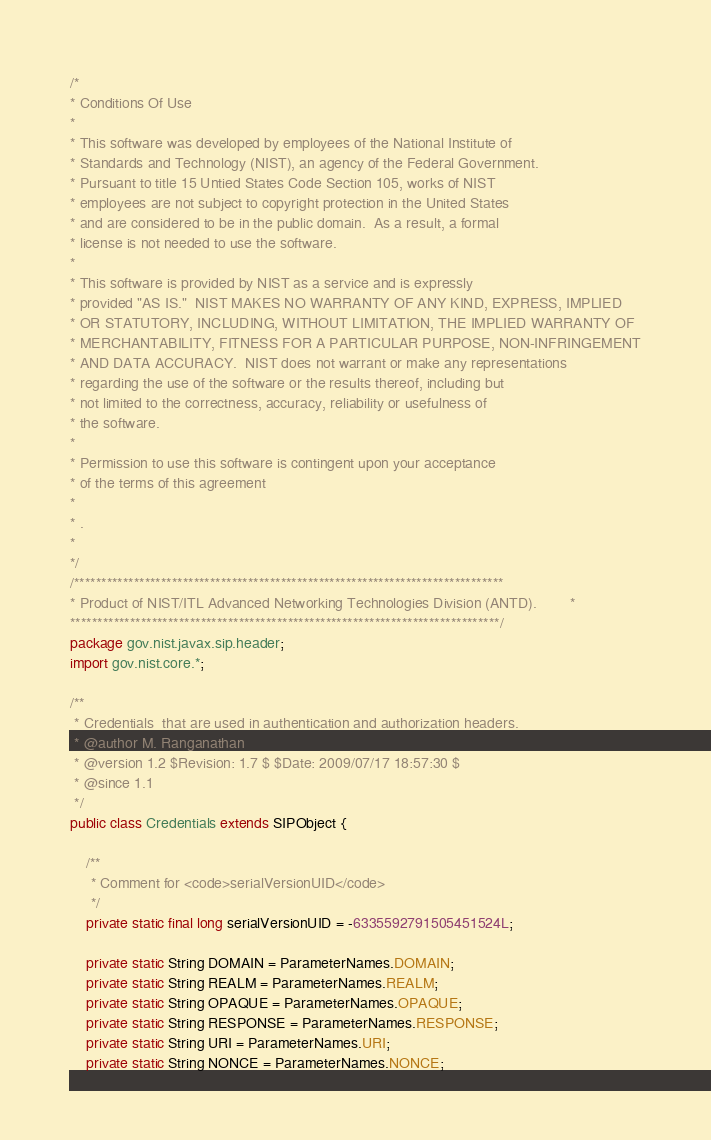Convert code to text. <code><loc_0><loc_0><loc_500><loc_500><_Java_>/*
* Conditions Of Use
*
* This software was developed by employees of the National Institute of
* Standards and Technology (NIST), an agency of the Federal Government.
* Pursuant to title 15 Untied States Code Section 105, works of NIST
* employees are not subject to copyright protection in the United States
* and are considered to be in the public domain.  As a result, a formal
* license is not needed to use the software.
*
* This software is provided by NIST as a service and is expressly
* provided "AS IS."  NIST MAKES NO WARRANTY OF ANY KIND, EXPRESS, IMPLIED
* OR STATUTORY, INCLUDING, WITHOUT LIMITATION, THE IMPLIED WARRANTY OF
* MERCHANTABILITY, FITNESS FOR A PARTICULAR PURPOSE, NON-INFRINGEMENT
* AND DATA ACCURACY.  NIST does not warrant or make any representations
* regarding the use of the software or the results thereof, including but
* not limited to the correctness, accuracy, reliability or usefulness of
* the software.
*
* Permission to use this software is contingent upon your acceptance
* of the terms of this agreement
*
* .
*
*/
/*******************************************************************************
* Product of NIST/ITL Advanced Networking Technologies Division (ANTD).        *
*******************************************************************************/
package gov.nist.javax.sip.header;
import gov.nist.core.*;

/**
 * Credentials  that are used in authentication and authorization headers.
 * @author M. Ranganathan
 * @version 1.2 $Revision: 1.7 $ $Date: 2009/07/17 18:57:30 $
 * @since 1.1
 */
public class Credentials extends SIPObject {

    /**
     * Comment for <code>serialVersionUID</code>
     */
    private static final long serialVersionUID = -6335592791505451524L;

    private static String DOMAIN = ParameterNames.DOMAIN;
    private static String REALM = ParameterNames.REALM;
    private static String OPAQUE = ParameterNames.OPAQUE;
    private static String RESPONSE = ParameterNames.RESPONSE;
    private static String URI = ParameterNames.URI;
    private static String NONCE = ParameterNames.NONCE;</code> 